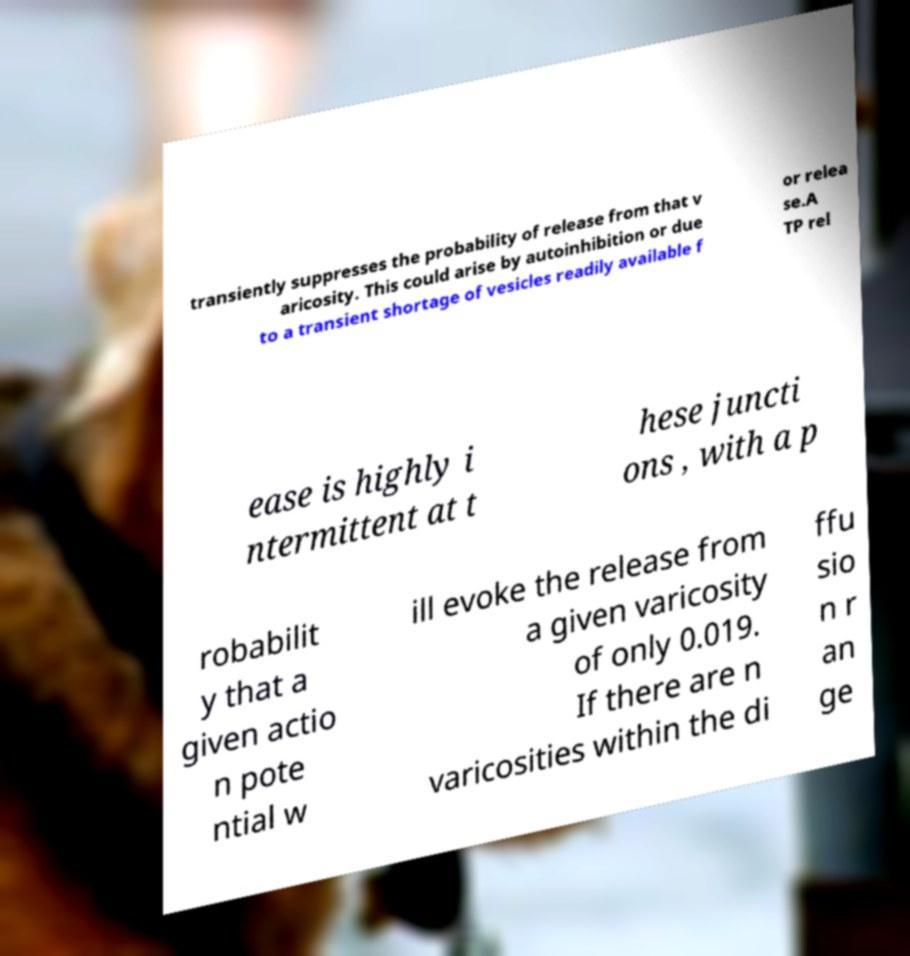Can you read and provide the text displayed in the image?This photo seems to have some interesting text. Can you extract and type it out for me? transiently suppresses the probability of release from that v aricosity. This could arise by autoinhibition or due to a transient shortage of vesicles readily available f or relea se.A TP rel ease is highly i ntermittent at t hese juncti ons , with a p robabilit y that a given actio n pote ntial w ill evoke the release from a given varicosity of only 0.019. If there are n varicosities within the di ffu sio n r an ge 